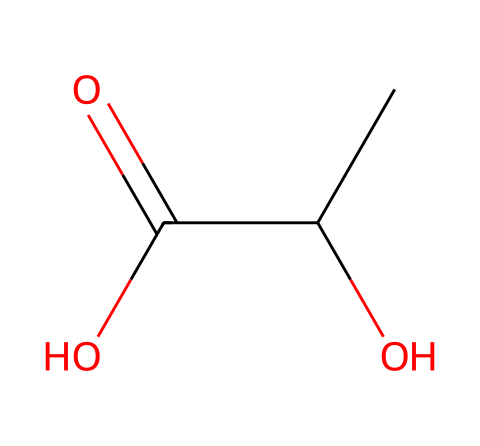What is the name of this chemical? The SMILES notation "CC(O)C(=O)O" corresponds to the structure of lactic acid, which is a common monomer used in biodegradable plastics.
Answer: lactic acid How many carbon atoms are present in this molecule? By examining the SMILES, there are two 'C' characters present, indicating two carbon atoms in the structure.
Answer: 2 What type of functional groups are present in lactic acid? The structure has a hydroxyl group (—OH) and a carboxylic acid group (—COOH), indicating the presence of both alcohol and acid functionalities.
Answer: hydroxyl and carboxylic acid How many oxygen atoms are in lactic acid? The SMILES includes two 'O' characters; hence, there are two oxygen atoms in the molecular structure.
Answer: 2 Why is lactic acid considered a good monomer for biodegradable plastics? Lactic acid is biodegradable due to its natural occurrence in metabolic processes, making it environmentally friendly and suitable for sustainable construction materials.
Answer: biodegradable What type of bond connects the functional groups in lactic acid? The carboxylic acid group (—COOH) is connected to the carbon chain with a single bond, typical for functional group connections in organic compounds.
Answer: single bond What is the molecular weight of lactic acid? The molecular weight can be calculated by adding the atomic weights of all atoms in the structure: 2 carbon (12.01 g/mol each) + 4 hydrogen (1.008 g/mol each) + 3 oxygen (16.00 g/mol each) = approximately 90.08 g/mol.
Answer: 90.08 g/mol 